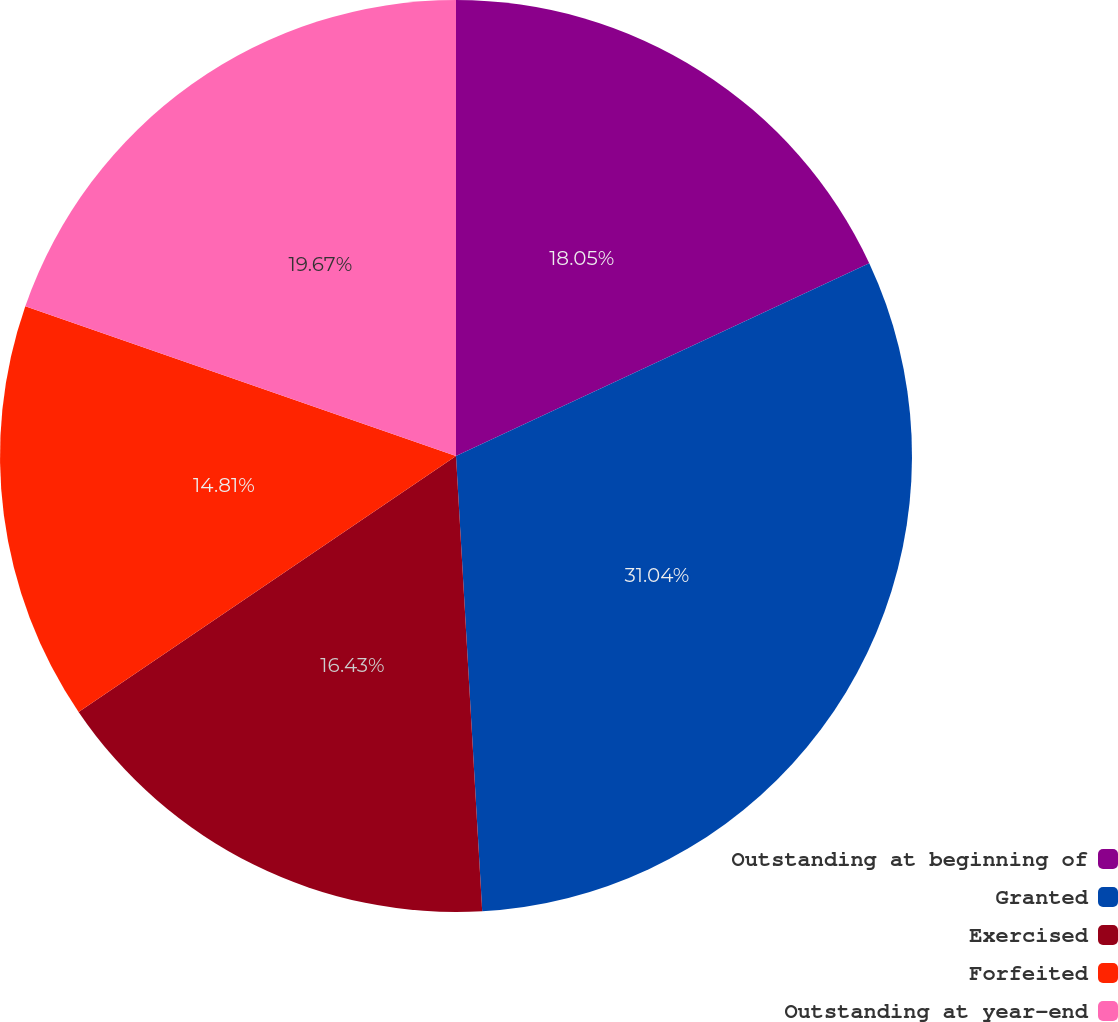Convert chart to OTSL. <chart><loc_0><loc_0><loc_500><loc_500><pie_chart><fcel>Outstanding at beginning of<fcel>Granted<fcel>Exercised<fcel>Forfeited<fcel>Outstanding at year-end<nl><fcel>18.05%<fcel>31.03%<fcel>16.43%<fcel>14.81%<fcel>19.67%<nl></chart> 